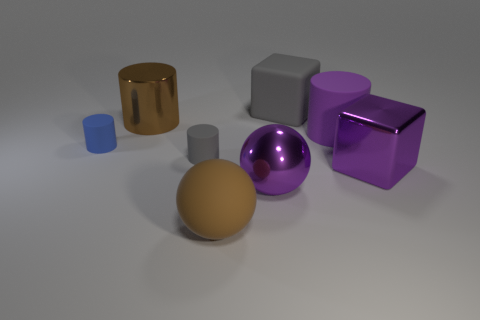Are there the same number of brown matte things on the right side of the big brown sphere and brown metal objects to the left of the big purple rubber object?
Your response must be concise. No. Does the matte cylinder on the right side of the gray matte block have the same color as the cube that is in front of the big brown cylinder?
Your response must be concise. Yes. Is the number of large things behind the metal block greater than the number of tiny green matte cylinders?
Give a very brief answer. Yes. The blue thing that is made of the same material as the tiny gray cylinder is what shape?
Provide a short and direct response. Cylinder. There is a shiny object that is behind the gray matte cylinder; is its size the same as the blue cylinder?
Your answer should be compact. No. The shiny object behind the object that is to the right of the big rubber cylinder is what shape?
Make the answer very short. Cylinder. How big is the brown thing that is behind the big rubber thing that is in front of the big purple matte cylinder?
Offer a very short reply. Large. There is a rubber object left of the large metallic cylinder; what is its color?
Make the answer very short. Blue. There is a blue thing that is the same material as the large gray block; what size is it?
Make the answer very short. Small. How many purple rubber things are the same shape as the brown matte object?
Ensure brevity in your answer.  0. 